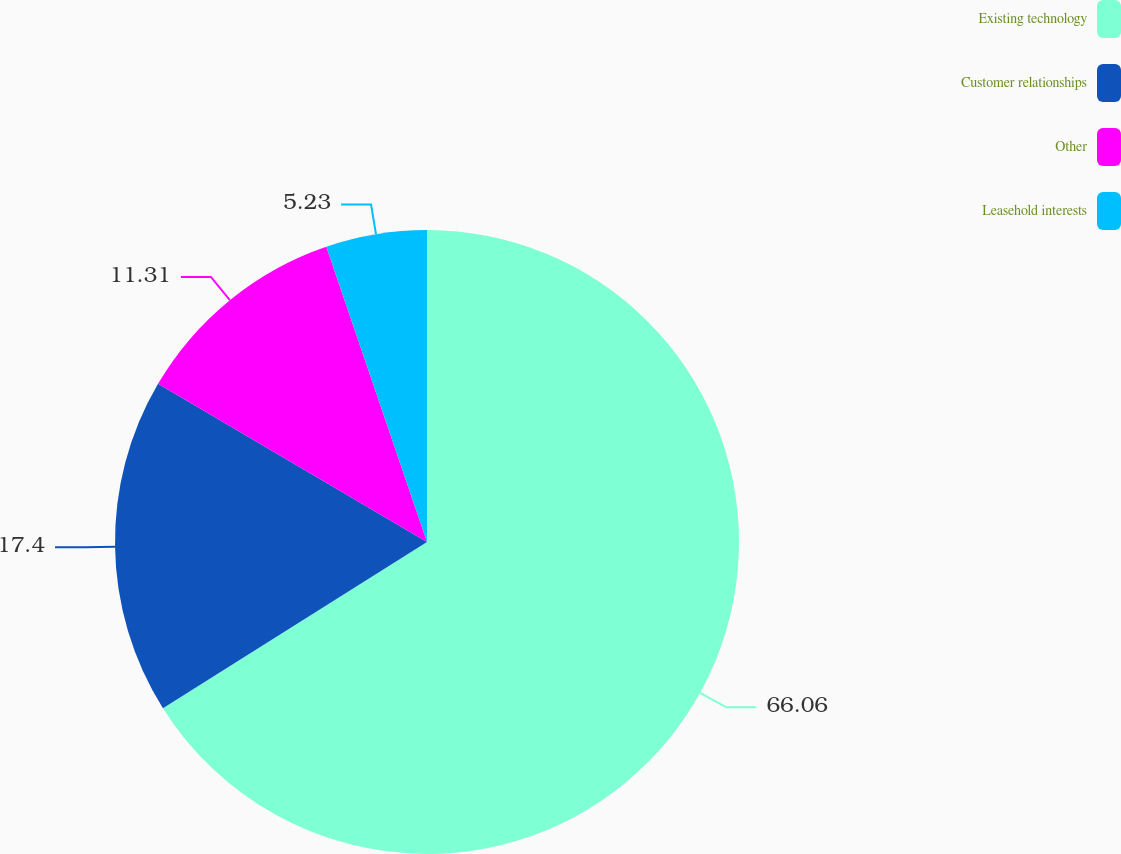Convert chart to OTSL. <chart><loc_0><loc_0><loc_500><loc_500><pie_chart><fcel>Existing technology<fcel>Customer relationships<fcel>Other<fcel>Leasehold interests<nl><fcel>66.06%<fcel>17.4%<fcel>11.31%<fcel>5.23%<nl></chart> 